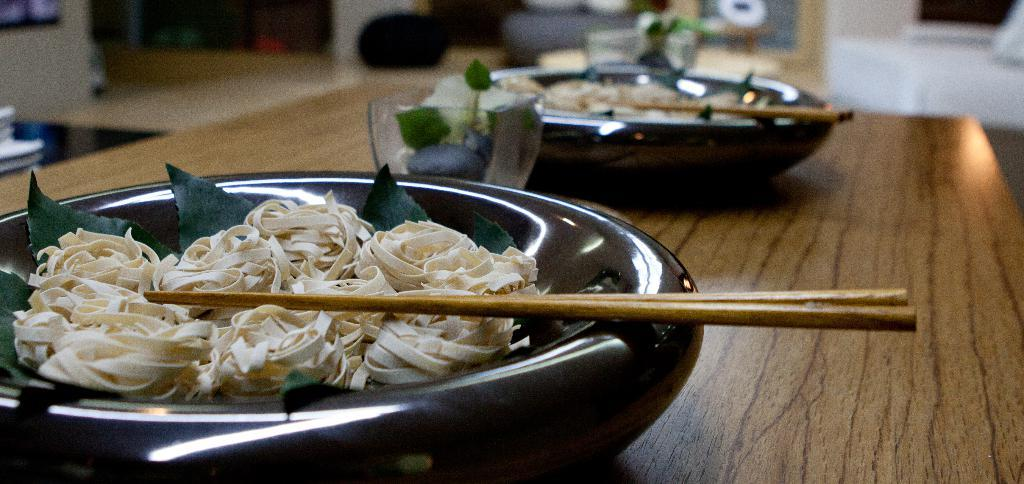What objects are on the table in the image? There are bowls, sticks, food, and a glass on the table. What might be used to eat the food on the table? The sticks on the table might be used to eat the food. What type of container is present on the table? There is a glass on the table. What type of business is being conducted in the garden in the image? There is no garden or business activity present in the image; it only shows objects on a table. 